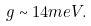<formula> <loc_0><loc_0><loc_500><loc_500>g \sim 1 4 m e V .</formula> 